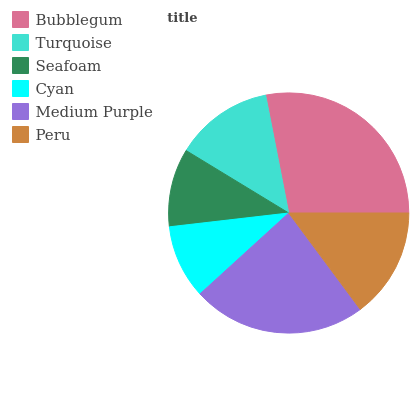Is Cyan the minimum?
Answer yes or no. Yes. Is Bubblegum the maximum?
Answer yes or no. Yes. Is Turquoise the minimum?
Answer yes or no. No. Is Turquoise the maximum?
Answer yes or no. No. Is Bubblegum greater than Turquoise?
Answer yes or no. Yes. Is Turquoise less than Bubblegum?
Answer yes or no. Yes. Is Turquoise greater than Bubblegum?
Answer yes or no. No. Is Bubblegum less than Turquoise?
Answer yes or no. No. Is Peru the high median?
Answer yes or no. Yes. Is Turquoise the low median?
Answer yes or no. Yes. Is Seafoam the high median?
Answer yes or no. No. Is Medium Purple the low median?
Answer yes or no. No. 